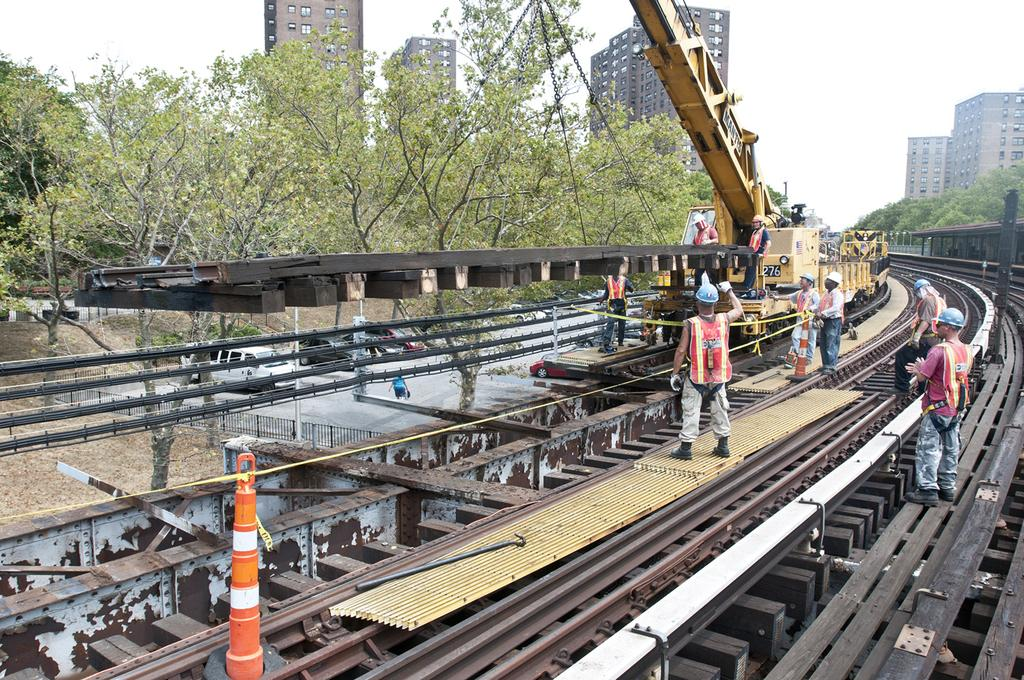What are the people in the image doing? The people in the image are working on the railway tracks. What type of machinery is present in the image? There is a crane in the image. What else can be seen in the image besides the people and the crane? There are vehicles, a fence, trees, buildings, and the sky visible in the image. What type of oil is being used by the people working on the railway tracks? There is no indication in the image that oil is being used by the people working on the railway tracks. 